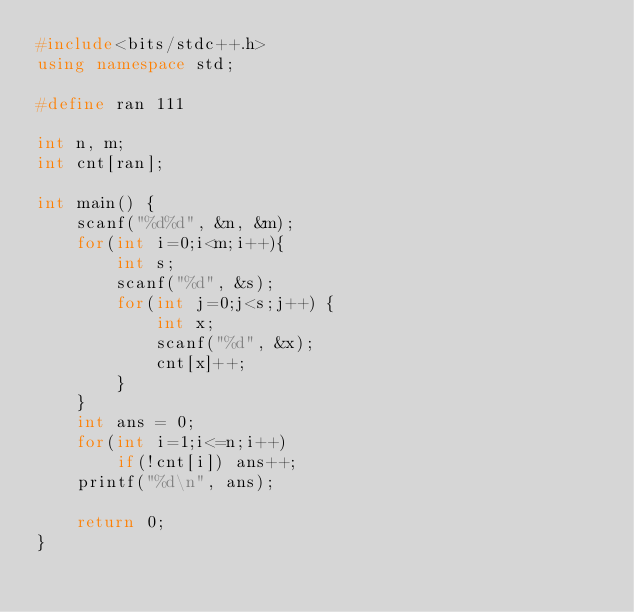<code> <loc_0><loc_0><loc_500><loc_500><_C++_>#include<bits/stdc++.h>
using namespace std;

#define ran 111

int n, m;
int cnt[ran];

int main() {
	scanf("%d%d", &n, &m);
	for(int i=0;i<m;i++){
		int s;
		scanf("%d", &s);
		for(int j=0;j<s;j++) {
			int x;
			scanf("%d", &x);
			cnt[x]++;
		}
	}
	int ans = 0;
	for(int i=1;i<=n;i++)
		if(!cnt[i]) ans++;
	printf("%d\n", ans);
	
	return 0;
}</code> 